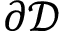<formula> <loc_0><loc_0><loc_500><loc_500>\partial \mathcal { D }</formula> 